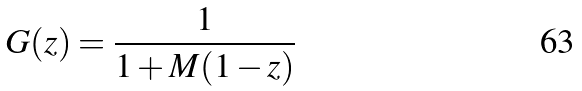<formula> <loc_0><loc_0><loc_500><loc_500>G ( z ) = \frac { 1 } { 1 + M ( 1 - z ) }</formula> 